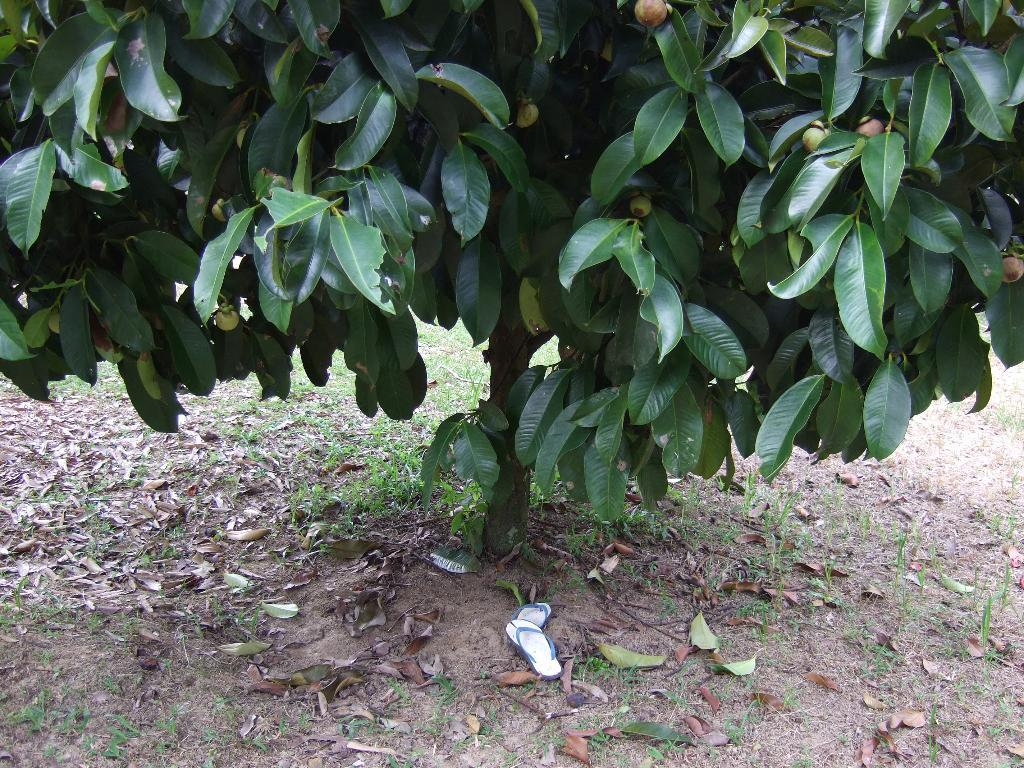What type of plant is depicted in the image? There is a tree with branches and leaves in the image. What is hanging from the tree? Fruits are hanging from the tree. What type of footwear is visible under the tree? A pair of sandals is visible under the tree. What is present on the ground in the image? There are leaves lying on the ground in the image. What type of chairs are used for measuring the height of the tree in the image? There are no chairs present in the image, and the height of the tree is not being measured. 